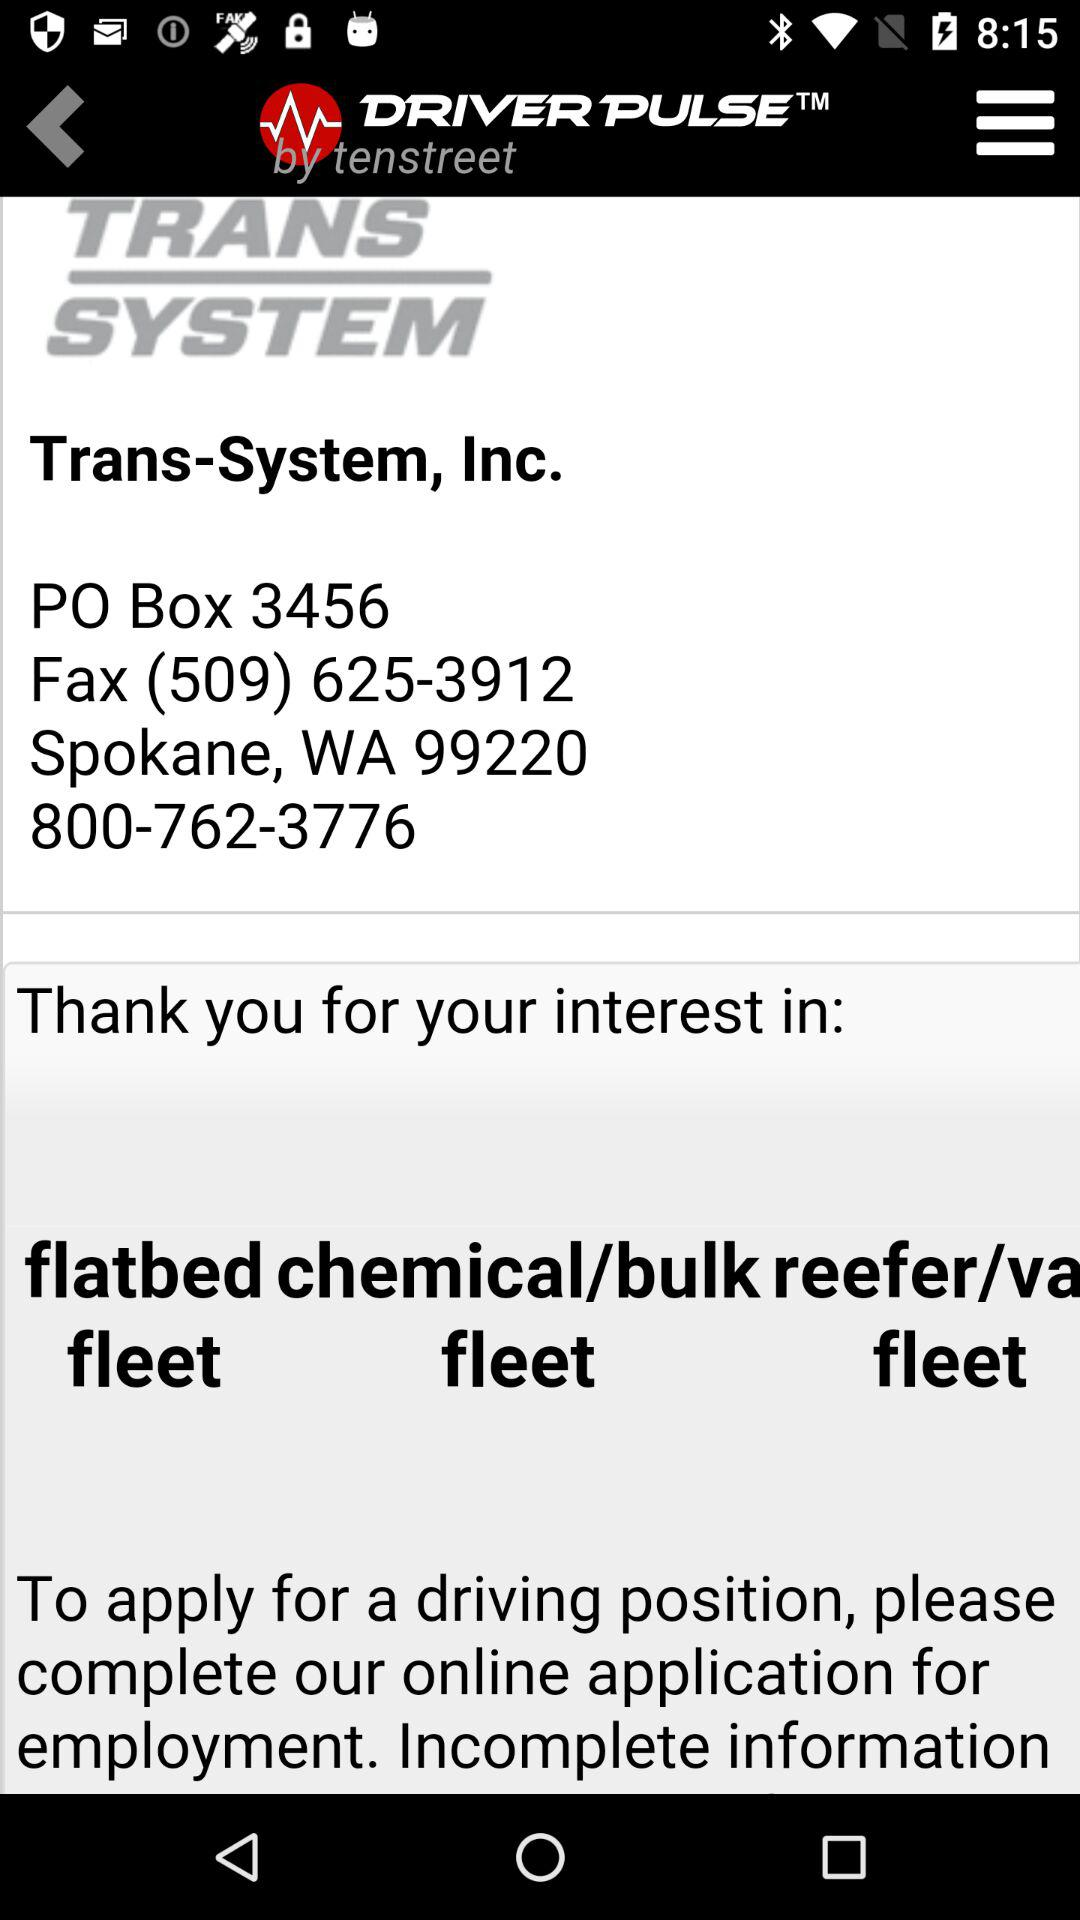What is the application name? The application name is "DRIVER PULSE". 